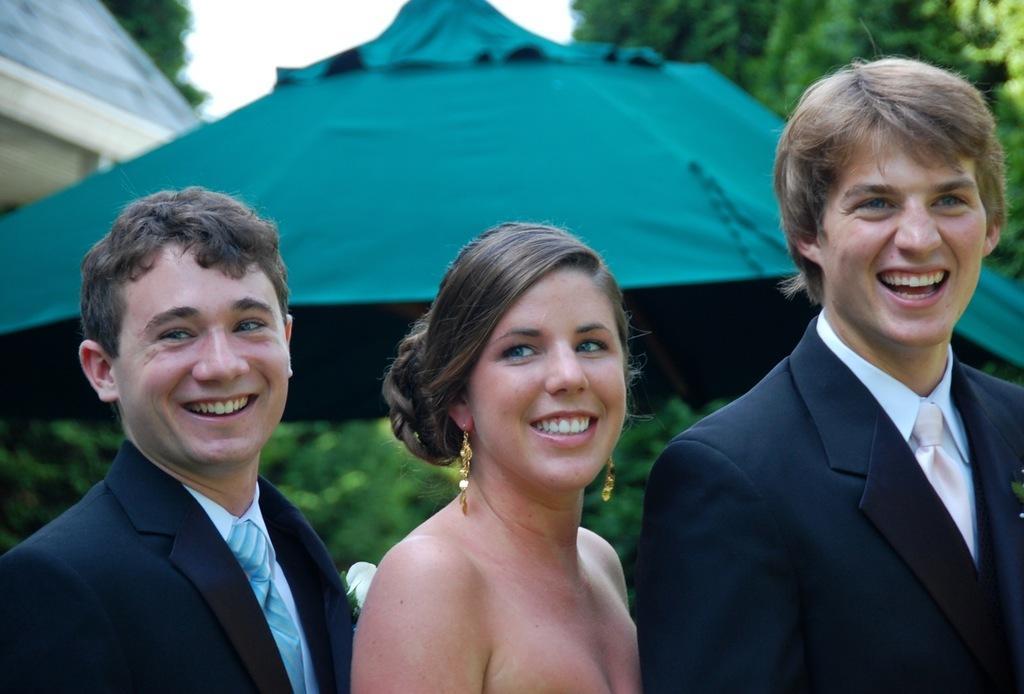In one or two sentences, can you explain what this image depicts? In this picture we can see a lady and two mans are standing. In the background of the image we can see trees, tent, house are there. At the top of the image there is a sky. 